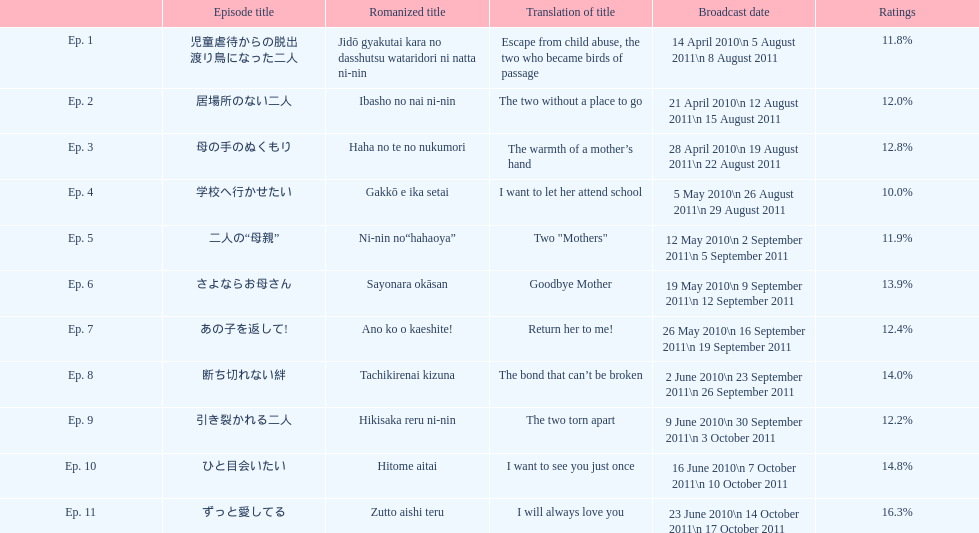What was the top rated episode of this show? ずっと愛してる. 